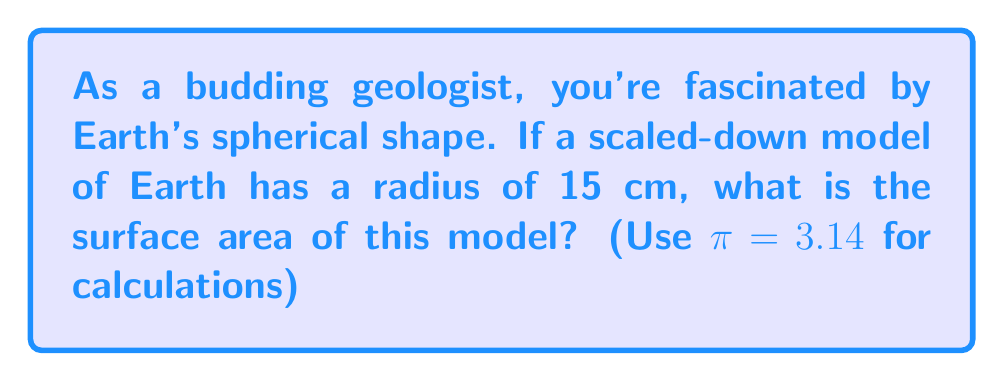Can you solve this math problem? To solve this problem, we'll use the formula for the surface area of a sphere:

$$A = 4\pi r^2$$

Where:
$A$ = surface area
$r$ = radius of the sphere

Given:
$r = 15$ cm
$\pi = 3.14$

Let's substitute these values into our formula:

$$\begin{align*}
A &= 4\pi r^2 \\
&= 4 \cdot 3.14 \cdot (15\text{ cm})^2 \\
&= 4 \cdot 3.14 \cdot 225\text{ cm}^2 \\
&= 2,826\text{ cm}^2
\end{align*}$$

This calculation gives us the surface area of our Earth model in square centimeters.

[asy]
import geometry;

size(200);
draw(circle((0,0),5), blue);
draw((0,0)--(5,0), arrow=Arrow(TeXHead));
label("15 cm", (2.5,0.5), N);
label("Earth model", (0,-6));
[/asy]
Answer: The surface area of the spherical Earth model is 2,826 cm². 